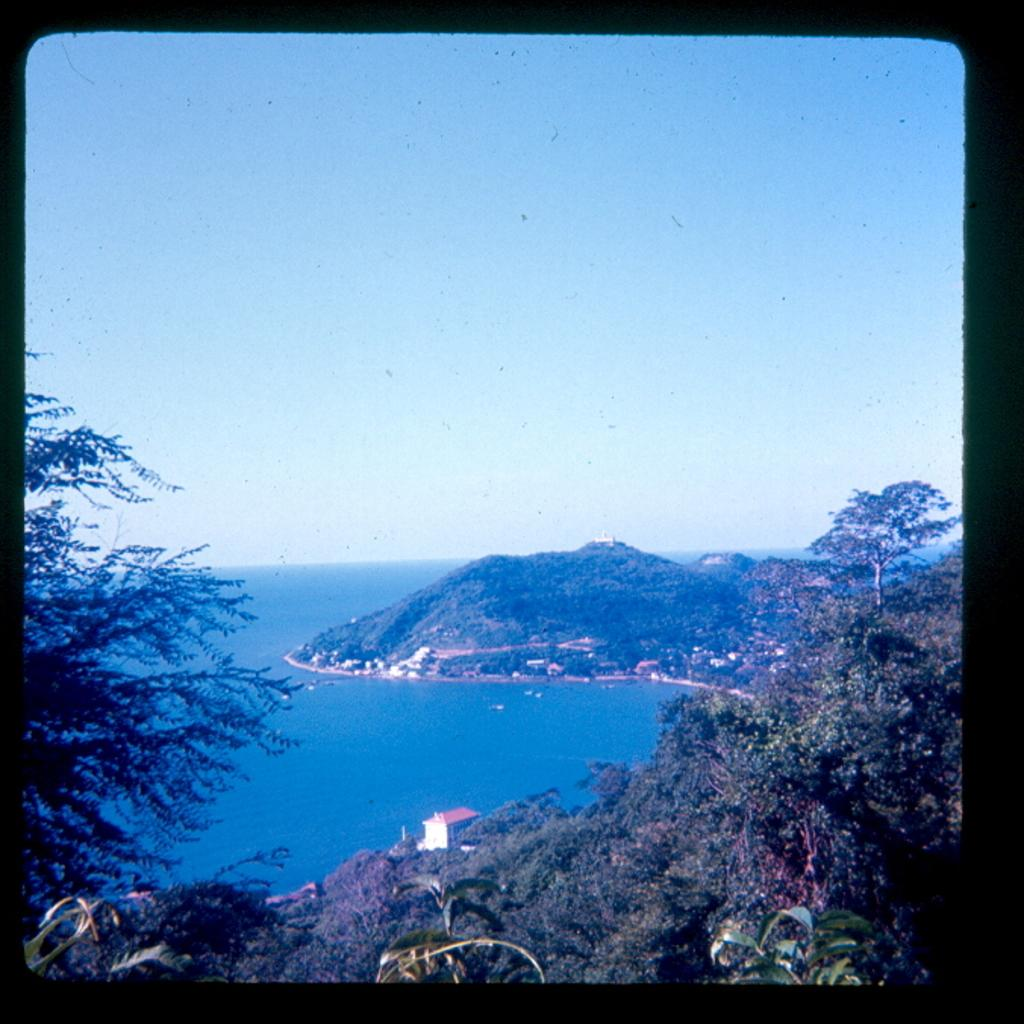What type of natural vegetation can be seen in the image? There are trees in the image. What geographical feature is present in the image? There is a mountain in the image. What type of human-made structures are visible in the image? There are houses in the image. What large body of water is visible in the image? The sea is visible in the image. What part of the natural environment is visible in the background of the image? The sky is visible in the background of the image. What type of substance is being transported by the yak in the image? There is no yak present in the image, so it is not possible to answer that question. What type of channel can be seen in the image? There is no channel present in the image; it features trees, a mountain, houses, the sea, and the sky. 